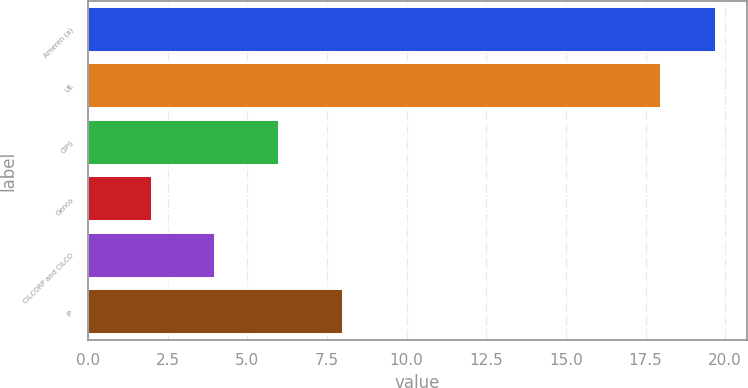Convert chart to OTSL. <chart><loc_0><loc_0><loc_500><loc_500><bar_chart><fcel>Ameren (a)<fcel>UE<fcel>CIPS<fcel>Genco<fcel>CILCORP and CILCO<fcel>IP<nl><fcel>19.7<fcel>18<fcel>6<fcel>2<fcel>4<fcel>8<nl></chart> 